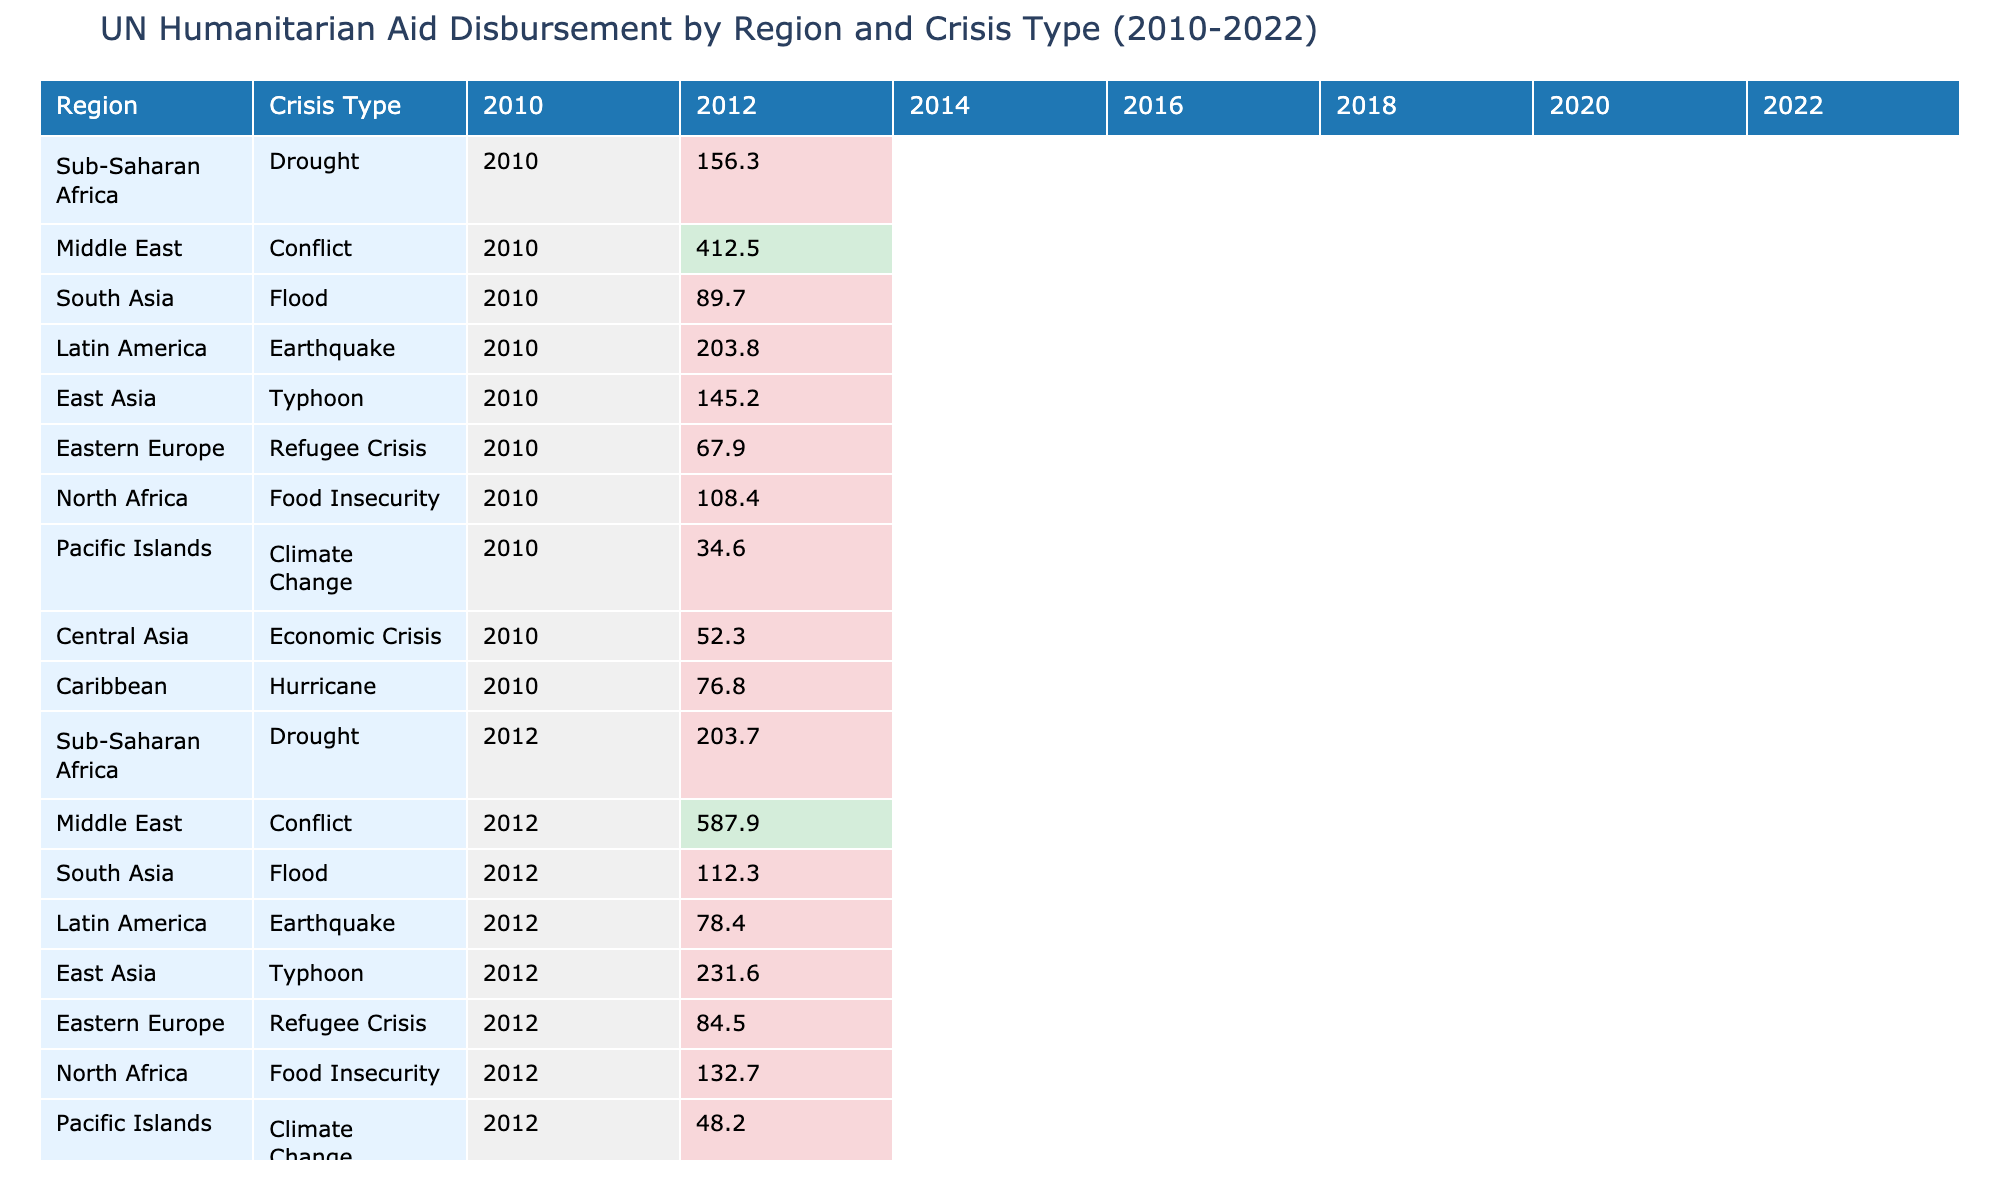What was the total UN humanitarian aid disbursed to Sub-Saharan Africa for drought in 2010 and 2022? The aid amounts for Sub-Saharan Africa due to drought in 2010 and 2022 are 156.3 and 342.8 respectively. Adding these two values gives a total of 156.3 + 342.8 = 499.1.
Answer: 499.1 Which region received the highest amount of aid for conflict in 2016? In 2016, the Middle East received the highest amount of aid for conflict, which is 1105.2.
Answer: 1105.2 Was the aid for food insecurity in North Africa higher in 2022 than in 2010? The aid for food insecurity in North Africa was 278.9 in 2022 and 108.4 in 2010. Since 278.9 > 108.4, the statement is true.
Answer: Yes What is the difference in aid amounts for climate change between 2010 and 2022 in Pacific Islands? The aid amounts for climate change in the Pacific Islands for 2010 and 2022 are 34.6 and 138.6 respectively. The difference is 138.6 - 34.6 = 104.0.
Answer: 104.0 How much aid was given to Eastern Europe for the refugee crisis in 2018 compared to 2022? Aid for Eastern Europe for the refugee crisis was 183.4 in 2018 and 387.2 in 2022. The increase is 387.2 - 183.4 = 203.8.
Answer: 203.8 Which crisis type in East Asia received the least aid in 2014? In East Asia, the typhoon crisis type received aid amounting to 287.4 in 2014. This is the only entry for East Asia in that year, thus it is the least by default.
Answer: 287.4 What region had the highest cumulative humanitarian aid amount from 2010 to 2022, and what was it? To find the cumulative amount, sums for each region need to be calculated. The Middle East has the highest cumulative aid total: 412.5 + 587.9 + 823.6 + 1105.2 + 978.4 + 891.7 + 1024.3 = 4823.6.
Answer: Middle East, 4823.6 Was the aid amount for hurricanes in the Caribbean increasing every two years from 2010 to 2022? The aid amounts for the Caribbean due to hurricanes were 76.8 in 2010, 89.7 in 2012, 176.2 in 2016, 234.5 in 2018, and 267.3 in 2022. The values do not increase every two years as 89.7 to 176.2 does, but 176.2 to 234.5 increases, while 89.7 to 76.8 decreases.
Answer: No 